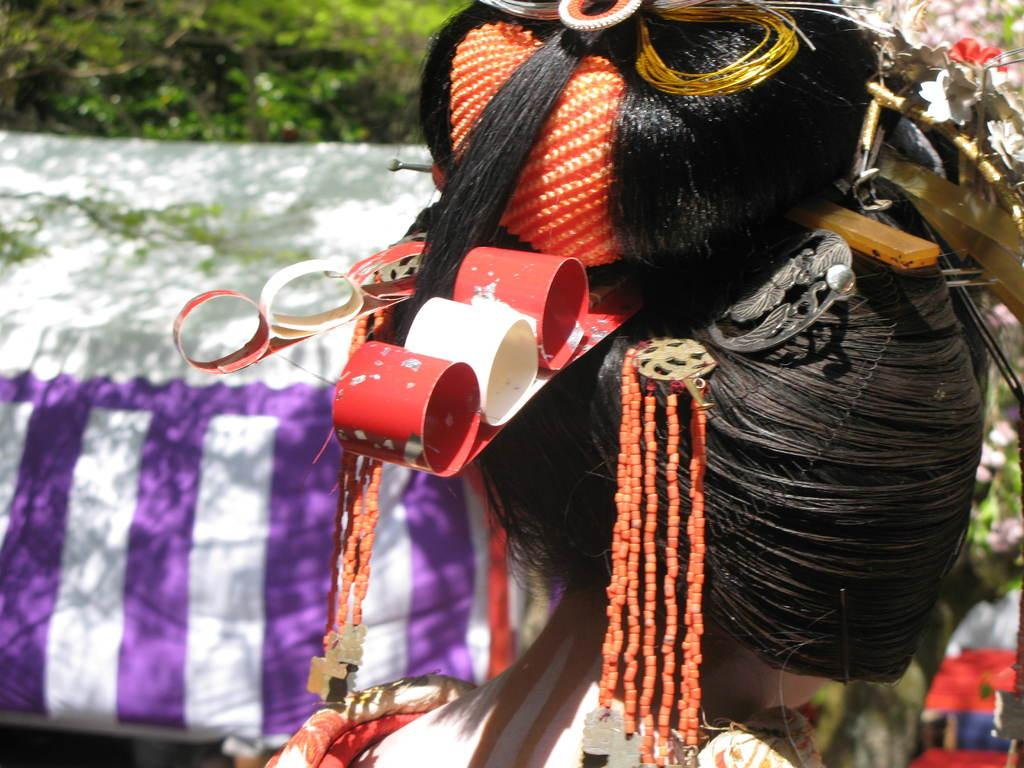Who is the main subject in the image? There is a girl in the image. How is the girl's hair styled in the image? The girl has a bun hairstyle in the image. What type of natural scenery can be seen in the image? There are trees visible in the image. What type of grain is being stored in the box in the image? There is no box or grain present in the image. How many lizards can be seen climbing the trees in the image? There are no lizards visible in the image; only the girl and trees are present. 